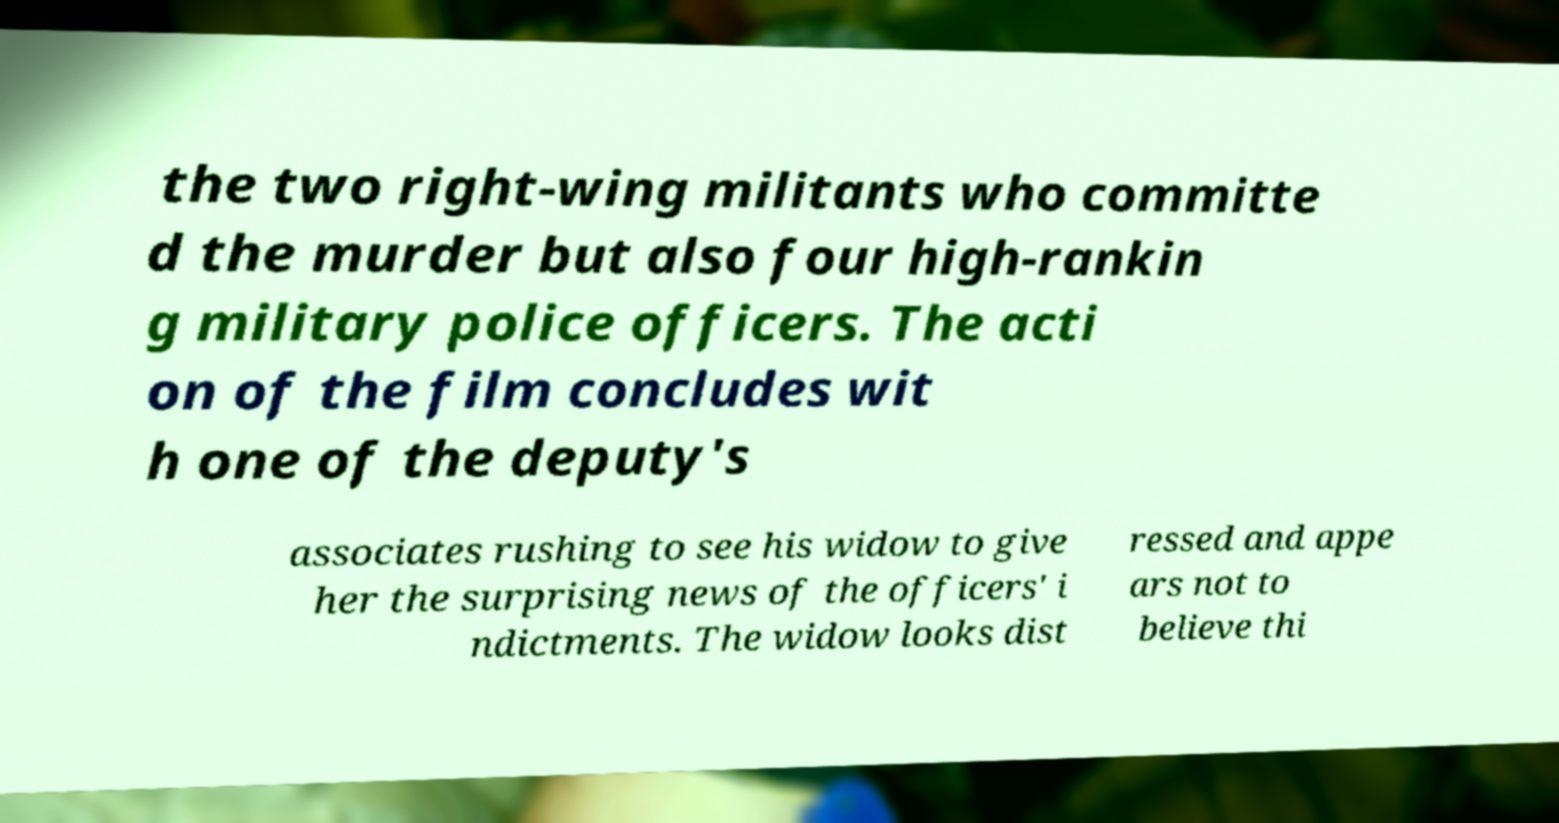Please read and relay the text visible in this image. What does it say? the two right-wing militants who committe d the murder but also four high-rankin g military police officers. The acti on of the film concludes wit h one of the deputy's associates rushing to see his widow to give her the surprising news of the officers' i ndictments. The widow looks dist ressed and appe ars not to believe thi 